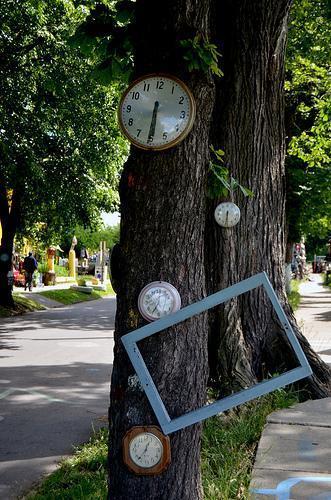How many clocks are visible?
Give a very brief answer. 4. How many clocks are on the first tree?
Give a very brief answer. 3. 